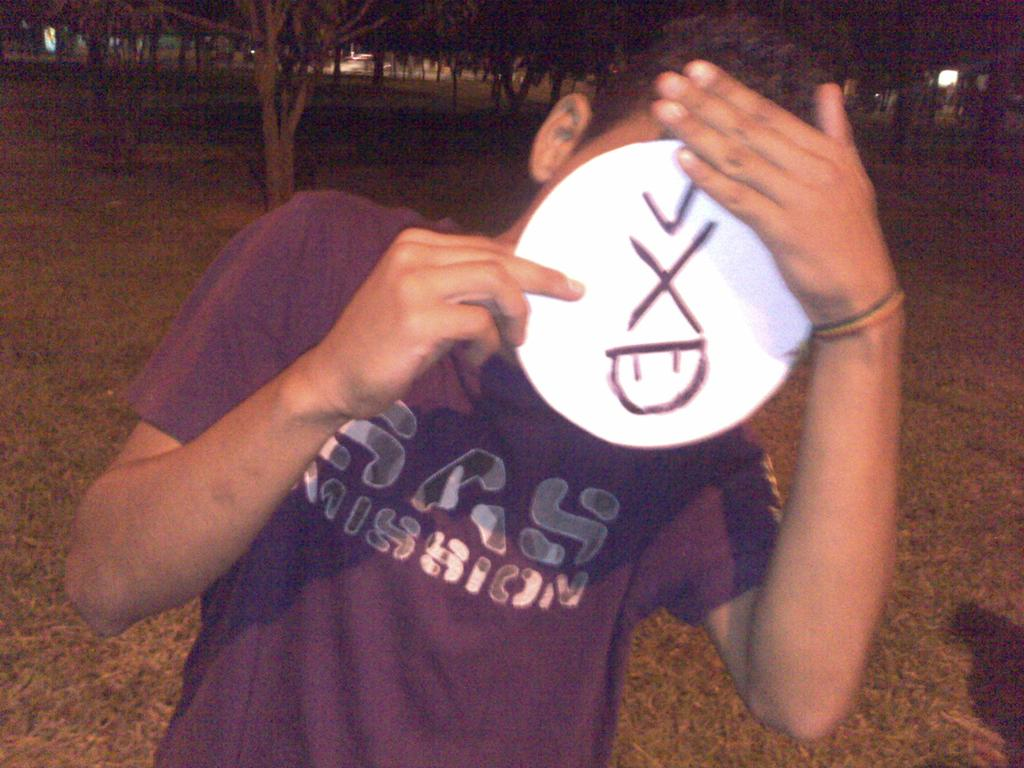<image>
Provide a brief description of the given image. Man holding up a circular cartoon face that is sticking its tongue out while wearing a Gas Mission shirt. 